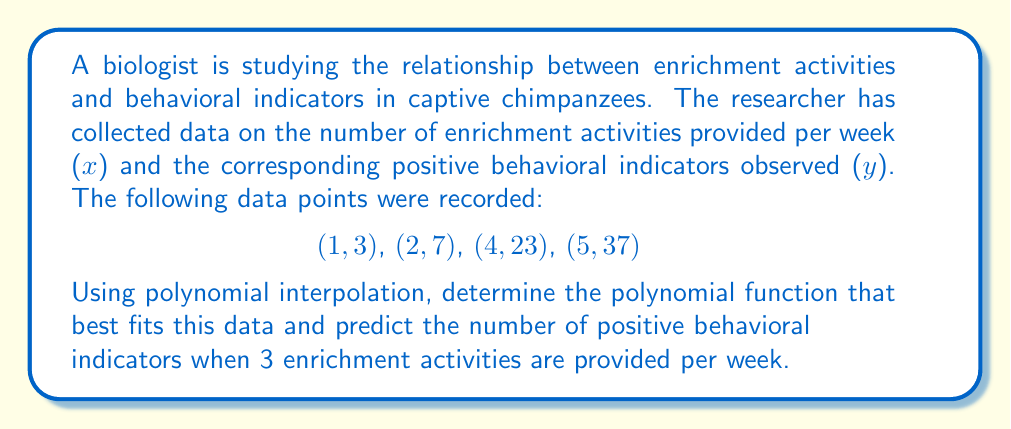Solve this math problem. To solve this problem, we'll use Lagrange polynomial interpolation to find the polynomial that passes through all given points.

1) The Lagrange interpolation polynomial is given by:

   $$P(x) = \sum_{i=1}^n y_i \cdot L_i(x)$$

   where $L_i(x)$ is the Lagrange basis polynomial:

   $$L_i(x) = \prod_{j \neq i} \frac{x - x_j}{x_i - x_j}$$

2) We have 4 points, so our polynomial will be of degree 3. Let's calculate each $L_i(x)$:

   $$L_1(x) = \frac{(x-2)(x-4)(x-5)}{(1-2)(1-4)(1-5)} = -\frac{1}{12}(x-2)(x-4)(x-5)$$
   $$L_2(x) = \frac{(x-1)(x-4)(x-5)}{(2-1)(2-4)(2-5)} = \frac{1}{6}(x-1)(x-4)(x-5)$$
   $$L_3(x) = \frac{(x-1)(x-2)(x-5)}{(4-1)(4-2)(4-5)} = -\frac{1}{6}(x-1)(x-2)(x-5)$$
   $$L_4(x) = \frac{(x-1)(x-2)(x-4)}{(5-1)(5-2)(5-4)} = \frac{1}{12}(x-1)(x-2)(x-4)$$

3) Now, we can form our polynomial:

   $$P(x) = 3 \cdot L_1(x) + 7 \cdot L_2(x) + 23 \cdot L_3(x) + 37 \cdot L_4(x)$$

4) Expanding and simplifying:

   $$P(x) = \frac{1}{4}x^3 - \frac{5}{4}x^2 + \frac{13}{4}x + 1$$

5) To predict the number of positive behavioral indicators when 3 enrichment activities are provided, we evaluate $P(3)$:

   $$P(3) = \frac{1}{4}(3^3) - \frac{5}{4}(3^2) + \frac{13}{4}(3) + 1 = \frac{27}{4} - \frac{45}{4} + \frac{39}{4} + 1 = \frac{25}{4} = 6.25$$
Answer: The polynomial function that best fits the data is $P(x) = \frac{1}{4}x^3 - \frac{5}{4}x^2 + \frac{13}{4}x + 1$. When 3 enrichment activities are provided per week, the predicted number of positive behavioral indicators is 6.25. 